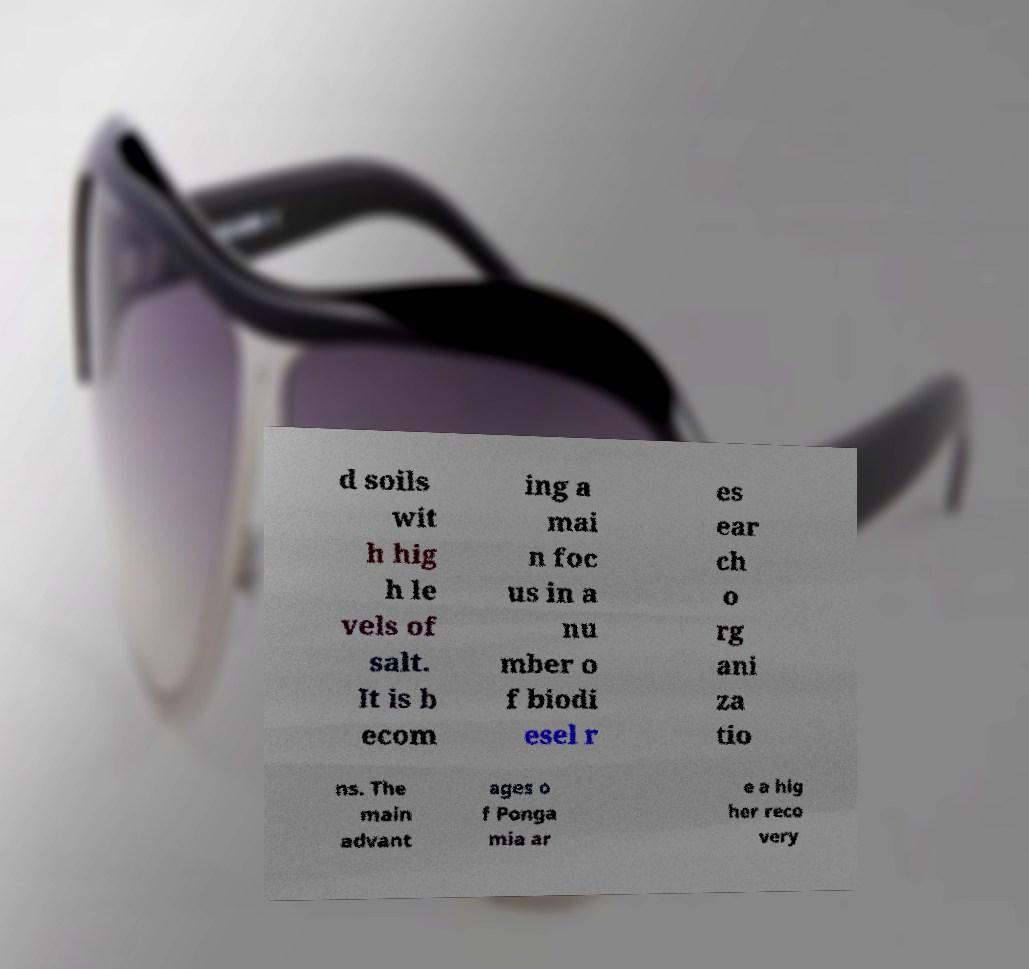Could you extract and type out the text from this image? d soils wit h hig h le vels of salt. It is b ecom ing a mai n foc us in a nu mber o f biodi esel r es ear ch o rg ani za tio ns. The main advant ages o f Ponga mia ar e a hig her reco very 